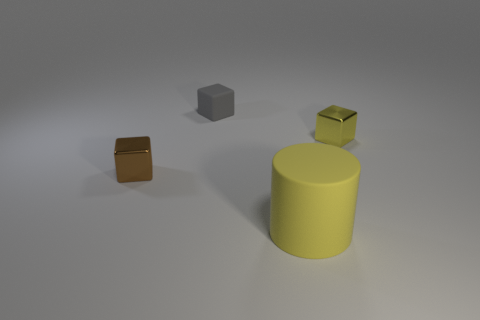Subtract all yellow cubes. How many cubes are left? 2 Add 4 yellow rubber objects. How many objects exist? 8 Subtract all brown cubes. How many cubes are left? 2 Subtract all blue cubes. Subtract all gray spheres. How many cubes are left? 3 Subtract all tiny green matte blocks. Subtract all large yellow things. How many objects are left? 3 Add 2 cylinders. How many cylinders are left? 3 Add 1 big matte cylinders. How many big matte cylinders exist? 2 Subtract 1 gray blocks. How many objects are left? 3 Subtract all blocks. How many objects are left? 1 